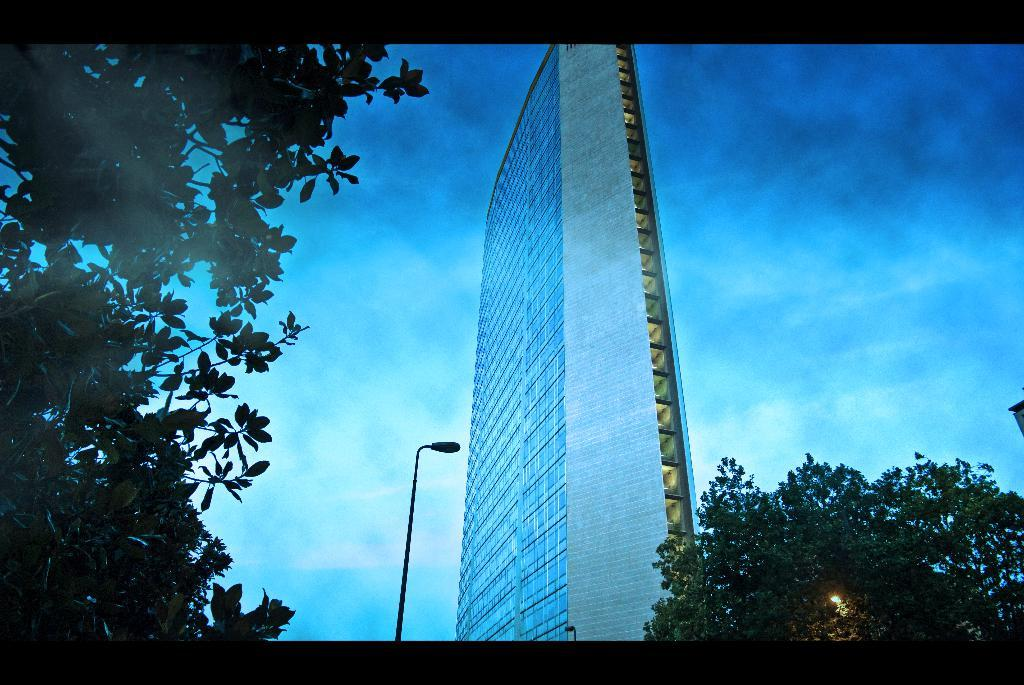What type of structure is visible in the image? There is a building with windows in the image. What can be seen illuminating the area in the image? There are street lights in the image. What type of vegetation is present in the image? There are trees in the image. What is visible in the background of the image? The sky is visible in the image, and clouds are present in the sky. What type of advice is being given by the cap in the image? There is no cap present in the image, and therefore no advice can be given by it. 